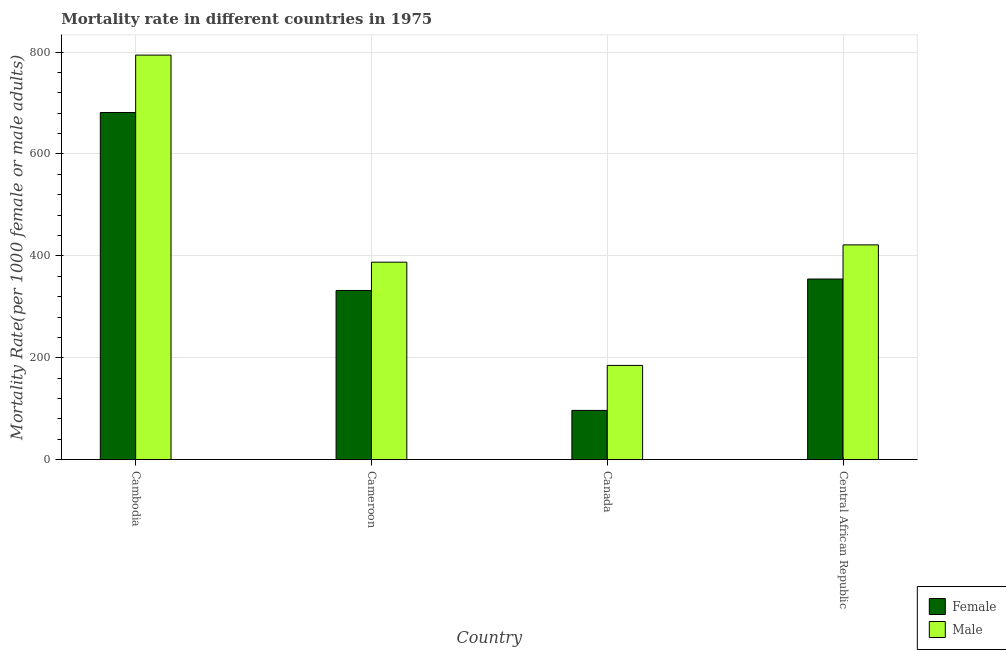How many different coloured bars are there?
Make the answer very short. 2. How many groups of bars are there?
Your response must be concise. 4. Are the number of bars per tick equal to the number of legend labels?
Keep it short and to the point. Yes. Are the number of bars on each tick of the X-axis equal?
Offer a terse response. Yes. How many bars are there on the 2nd tick from the right?
Make the answer very short. 2. What is the label of the 2nd group of bars from the left?
Provide a short and direct response. Cameroon. What is the female mortality rate in Cameroon?
Give a very brief answer. 332.12. Across all countries, what is the maximum female mortality rate?
Give a very brief answer. 681.35. Across all countries, what is the minimum male mortality rate?
Ensure brevity in your answer.  184.98. In which country was the female mortality rate maximum?
Your answer should be very brief. Cambodia. In which country was the male mortality rate minimum?
Provide a succinct answer. Canada. What is the total male mortality rate in the graph?
Offer a very short reply. 1788.11. What is the difference between the male mortality rate in Cambodia and that in Central African Republic?
Provide a succinct answer. 372.42. What is the difference between the male mortality rate in Canada and the female mortality rate in Central African Republic?
Offer a very short reply. -169.57. What is the average female mortality rate per country?
Provide a succinct answer. 366.18. What is the difference between the female mortality rate and male mortality rate in Canada?
Your answer should be very brief. -88.27. In how many countries, is the male mortality rate greater than 80 ?
Provide a succinct answer. 4. What is the ratio of the male mortality rate in Cameroon to that in Canada?
Provide a short and direct response. 2.1. Is the difference between the male mortality rate in Canada and Central African Republic greater than the difference between the female mortality rate in Canada and Central African Republic?
Make the answer very short. Yes. What is the difference between the highest and the second highest female mortality rate?
Your answer should be very brief. 326.8. What is the difference between the highest and the lowest male mortality rate?
Provide a succinct answer. 608.99. How many bars are there?
Offer a very short reply. 8. What is the difference between two consecutive major ticks on the Y-axis?
Your answer should be compact. 200. Are the values on the major ticks of Y-axis written in scientific E-notation?
Provide a short and direct response. No. Does the graph contain grids?
Provide a succinct answer. Yes. How are the legend labels stacked?
Keep it short and to the point. Vertical. What is the title of the graph?
Make the answer very short. Mortality rate in different countries in 1975. Does "Time to export" appear as one of the legend labels in the graph?
Your response must be concise. No. What is the label or title of the X-axis?
Give a very brief answer. Country. What is the label or title of the Y-axis?
Keep it short and to the point. Mortality Rate(per 1000 female or male adults). What is the Mortality Rate(per 1000 female or male adults) of Female in Cambodia?
Your answer should be compact. 681.35. What is the Mortality Rate(per 1000 female or male adults) of Male in Cambodia?
Offer a very short reply. 793.97. What is the Mortality Rate(per 1000 female or male adults) in Female in Cameroon?
Your answer should be very brief. 332.12. What is the Mortality Rate(per 1000 female or male adults) in Male in Cameroon?
Your answer should be compact. 387.6. What is the Mortality Rate(per 1000 female or male adults) in Female in Canada?
Offer a terse response. 96.71. What is the Mortality Rate(per 1000 female or male adults) in Male in Canada?
Provide a succinct answer. 184.98. What is the Mortality Rate(per 1000 female or male adults) in Female in Central African Republic?
Ensure brevity in your answer.  354.55. What is the Mortality Rate(per 1000 female or male adults) of Male in Central African Republic?
Offer a terse response. 421.56. Across all countries, what is the maximum Mortality Rate(per 1000 female or male adults) of Female?
Offer a terse response. 681.35. Across all countries, what is the maximum Mortality Rate(per 1000 female or male adults) of Male?
Make the answer very short. 793.97. Across all countries, what is the minimum Mortality Rate(per 1000 female or male adults) in Female?
Keep it short and to the point. 96.71. Across all countries, what is the minimum Mortality Rate(per 1000 female or male adults) of Male?
Ensure brevity in your answer.  184.98. What is the total Mortality Rate(per 1000 female or male adults) in Female in the graph?
Keep it short and to the point. 1464.74. What is the total Mortality Rate(per 1000 female or male adults) of Male in the graph?
Offer a very short reply. 1788.11. What is the difference between the Mortality Rate(per 1000 female or male adults) of Female in Cambodia and that in Cameroon?
Give a very brief answer. 349.23. What is the difference between the Mortality Rate(per 1000 female or male adults) in Male in Cambodia and that in Cameroon?
Your answer should be very brief. 406.37. What is the difference between the Mortality Rate(per 1000 female or male adults) in Female in Cambodia and that in Canada?
Your answer should be very brief. 584.64. What is the difference between the Mortality Rate(per 1000 female or male adults) of Male in Cambodia and that in Canada?
Provide a succinct answer. 608.99. What is the difference between the Mortality Rate(per 1000 female or male adults) in Female in Cambodia and that in Central African Republic?
Your answer should be very brief. 326.8. What is the difference between the Mortality Rate(per 1000 female or male adults) in Male in Cambodia and that in Central African Republic?
Provide a succinct answer. 372.42. What is the difference between the Mortality Rate(per 1000 female or male adults) of Female in Cameroon and that in Canada?
Offer a very short reply. 235.41. What is the difference between the Mortality Rate(per 1000 female or male adults) of Male in Cameroon and that in Canada?
Give a very brief answer. 202.62. What is the difference between the Mortality Rate(per 1000 female or male adults) in Female in Cameroon and that in Central African Republic?
Ensure brevity in your answer.  -22.43. What is the difference between the Mortality Rate(per 1000 female or male adults) of Male in Cameroon and that in Central African Republic?
Your answer should be compact. -33.96. What is the difference between the Mortality Rate(per 1000 female or male adults) of Female in Canada and that in Central African Republic?
Ensure brevity in your answer.  -257.84. What is the difference between the Mortality Rate(per 1000 female or male adults) in Male in Canada and that in Central African Republic?
Ensure brevity in your answer.  -236.58. What is the difference between the Mortality Rate(per 1000 female or male adults) in Female in Cambodia and the Mortality Rate(per 1000 female or male adults) in Male in Cameroon?
Your answer should be compact. 293.75. What is the difference between the Mortality Rate(per 1000 female or male adults) of Female in Cambodia and the Mortality Rate(per 1000 female or male adults) of Male in Canada?
Make the answer very short. 496.37. What is the difference between the Mortality Rate(per 1000 female or male adults) of Female in Cambodia and the Mortality Rate(per 1000 female or male adults) of Male in Central African Republic?
Offer a very short reply. 259.79. What is the difference between the Mortality Rate(per 1000 female or male adults) in Female in Cameroon and the Mortality Rate(per 1000 female or male adults) in Male in Canada?
Provide a succinct answer. 147.14. What is the difference between the Mortality Rate(per 1000 female or male adults) of Female in Cameroon and the Mortality Rate(per 1000 female or male adults) of Male in Central African Republic?
Provide a succinct answer. -89.44. What is the difference between the Mortality Rate(per 1000 female or male adults) of Female in Canada and the Mortality Rate(per 1000 female or male adults) of Male in Central African Republic?
Your response must be concise. -324.85. What is the average Mortality Rate(per 1000 female or male adults) of Female per country?
Provide a succinct answer. 366.18. What is the average Mortality Rate(per 1000 female or male adults) of Male per country?
Ensure brevity in your answer.  447.03. What is the difference between the Mortality Rate(per 1000 female or male adults) of Female and Mortality Rate(per 1000 female or male adults) of Male in Cambodia?
Your answer should be compact. -112.62. What is the difference between the Mortality Rate(per 1000 female or male adults) of Female and Mortality Rate(per 1000 female or male adults) of Male in Cameroon?
Your answer should be very brief. -55.48. What is the difference between the Mortality Rate(per 1000 female or male adults) of Female and Mortality Rate(per 1000 female or male adults) of Male in Canada?
Give a very brief answer. -88.27. What is the difference between the Mortality Rate(per 1000 female or male adults) of Female and Mortality Rate(per 1000 female or male adults) of Male in Central African Republic?
Ensure brevity in your answer.  -67.01. What is the ratio of the Mortality Rate(per 1000 female or male adults) of Female in Cambodia to that in Cameroon?
Offer a terse response. 2.05. What is the ratio of the Mortality Rate(per 1000 female or male adults) of Male in Cambodia to that in Cameroon?
Offer a very short reply. 2.05. What is the ratio of the Mortality Rate(per 1000 female or male adults) in Female in Cambodia to that in Canada?
Offer a very short reply. 7.05. What is the ratio of the Mortality Rate(per 1000 female or male adults) of Male in Cambodia to that in Canada?
Ensure brevity in your answer.  4.29. What is the ratio of the Mortality Rate(per 1000 female or male adults) in Female in Cambodia to that in Central African Republic?
Your response must be concise. 1.92. What is the ratio of the Mortality Rate(per 1000 female or male adults) of Male in Cambodia to that in Central African Republic?
Keep it short and to the point. 1.88. What is the ratio of the Mortality Rate(per 1000 female or male adults) of Female in Cameroon to that in Canada?
Ensure brevity in your answer.  3.43. What is the ratio of the Mortality Rate(per 1000 female or male adults) of Male in Cameroon to that in Canada?
Your answer should be very brief. 2.1. What is the ratio of the Mortality Rate(per 1000 female or male adults) in Female in Cameroon to that in Central African Republic?
Make the answer very short. 0.94. What is the ratio of the Mortality Rate(per 1000 female or male adults) in Male in Cameroon to that in Central African Republic?
Ensure brevity in your answer.  0.92. What is the ratio of the Mortality Rate(per 1000 female or male adults) in Female in Canada to that in Central African Republic?
Keep it short and to the point. 0.27. What is the ratio of the Mortality Rate(per 1000 female or male adults) in Male in Canada to that in Central African Republic?
Your answer should be very brief. 0.44. What is the difference between the highest and the second highest Mortality Rate(per 1000 female or male adults) of Female?
Provide a succinct answer. 326.8. What is the difference between the highest and the second highest Mortality Rate(per 1000 female or male adults) in Male?
Provide a succinct answer. 372.42. What is the difference between the highest and the lowest Mortality Rate(per 1000 female or male adults) of Female?
Ensure brevity in your answer.  584.64. What is the difference between the highest and the lowest Mortality Rate(per 1000 female or male adults) in Male?
Your answer should be very brief. 608.99. 